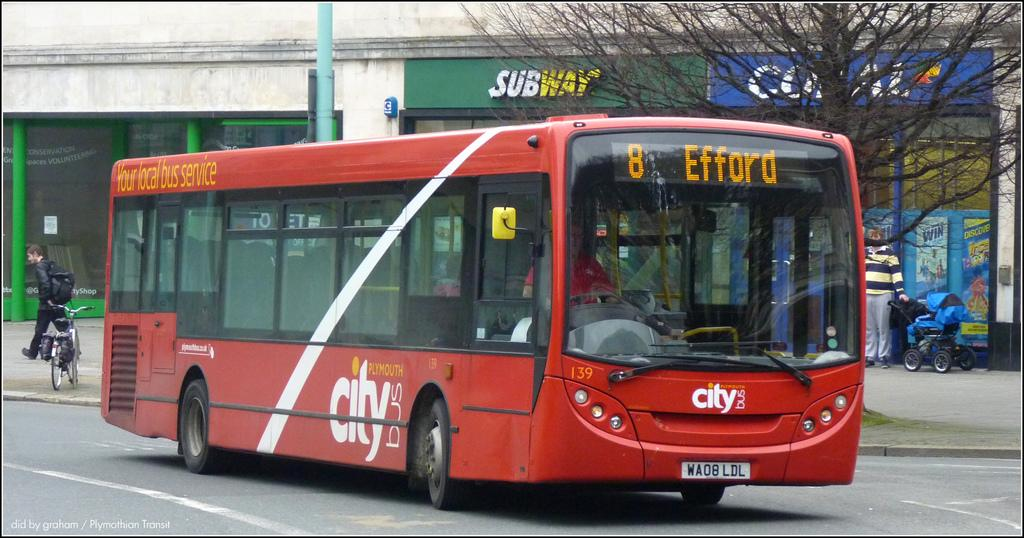Provide a one-sentence caption for the provided image. The big red city bus is stopping at efford. 